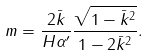<formula> <loc_0><loc_0><loc_500><loc_500>m = \frac { 2 \bar { k } } { H \alpha ^ { \prime } } \frac { \sqrt { 1 - \bar { k } ^ { 2 } } } { 1 - 2 \bar { k } ^ { 2 } } .</formula> 